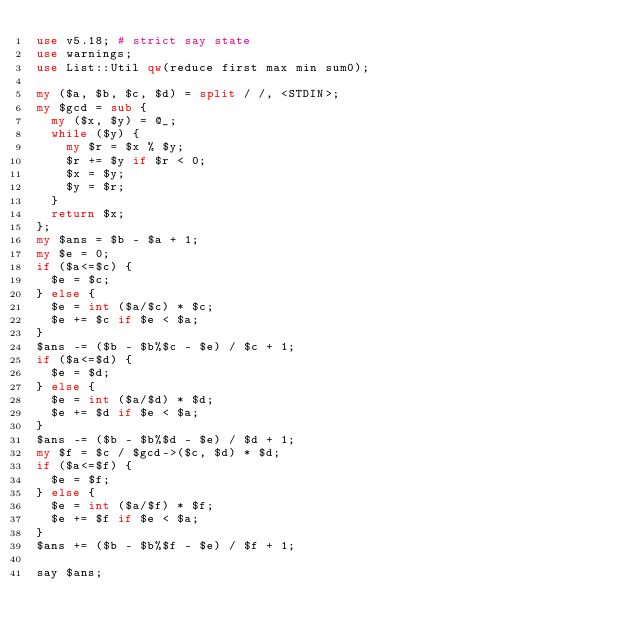<code> <loc_0><loc_0><loc_500><loc_500><_Perl_>use v5.18; # strict say state
use warnings;
use List::Util qw(reduce first max min sum0);

my ($a, $b, $c, $d) = split / /, <STDIN>;
my $gcd = sub {
  my ($x, $y) = @_;
  while ($y) {
    my $r = $x % $y;
    $r += $y if $r < 0;
    $x = $y;
    $y = $r;
  }
  return $x;
};
my $ans = $b - $a + 1;
my $e = 0;
if ($a<=$c) {
  $e = $c;
} else {
  $e = int ($a/$c) * $c;
  $e += $c if $e < $a;
}
$ans -= ($b - $b%$c - $e) / $c + 1;
if ($a<=$d) {
  $e = $d;
} else {
  $e = int ($a/$d) * $d;
  $e += $d if $e < $a;
}
$ans -= ($b - $b%$d - $e) / $d + 1;
my $f = $c / $gcd->($c, $d) * $d;
if ($a<=$f) {
  $e = $f;
} else {
  $e = int ($a/$f) * $f;
  $e += $f if $e < $a;
}
$ans += ($b - $b%$f - $e) / $f + 1;

say $ans;</code> 